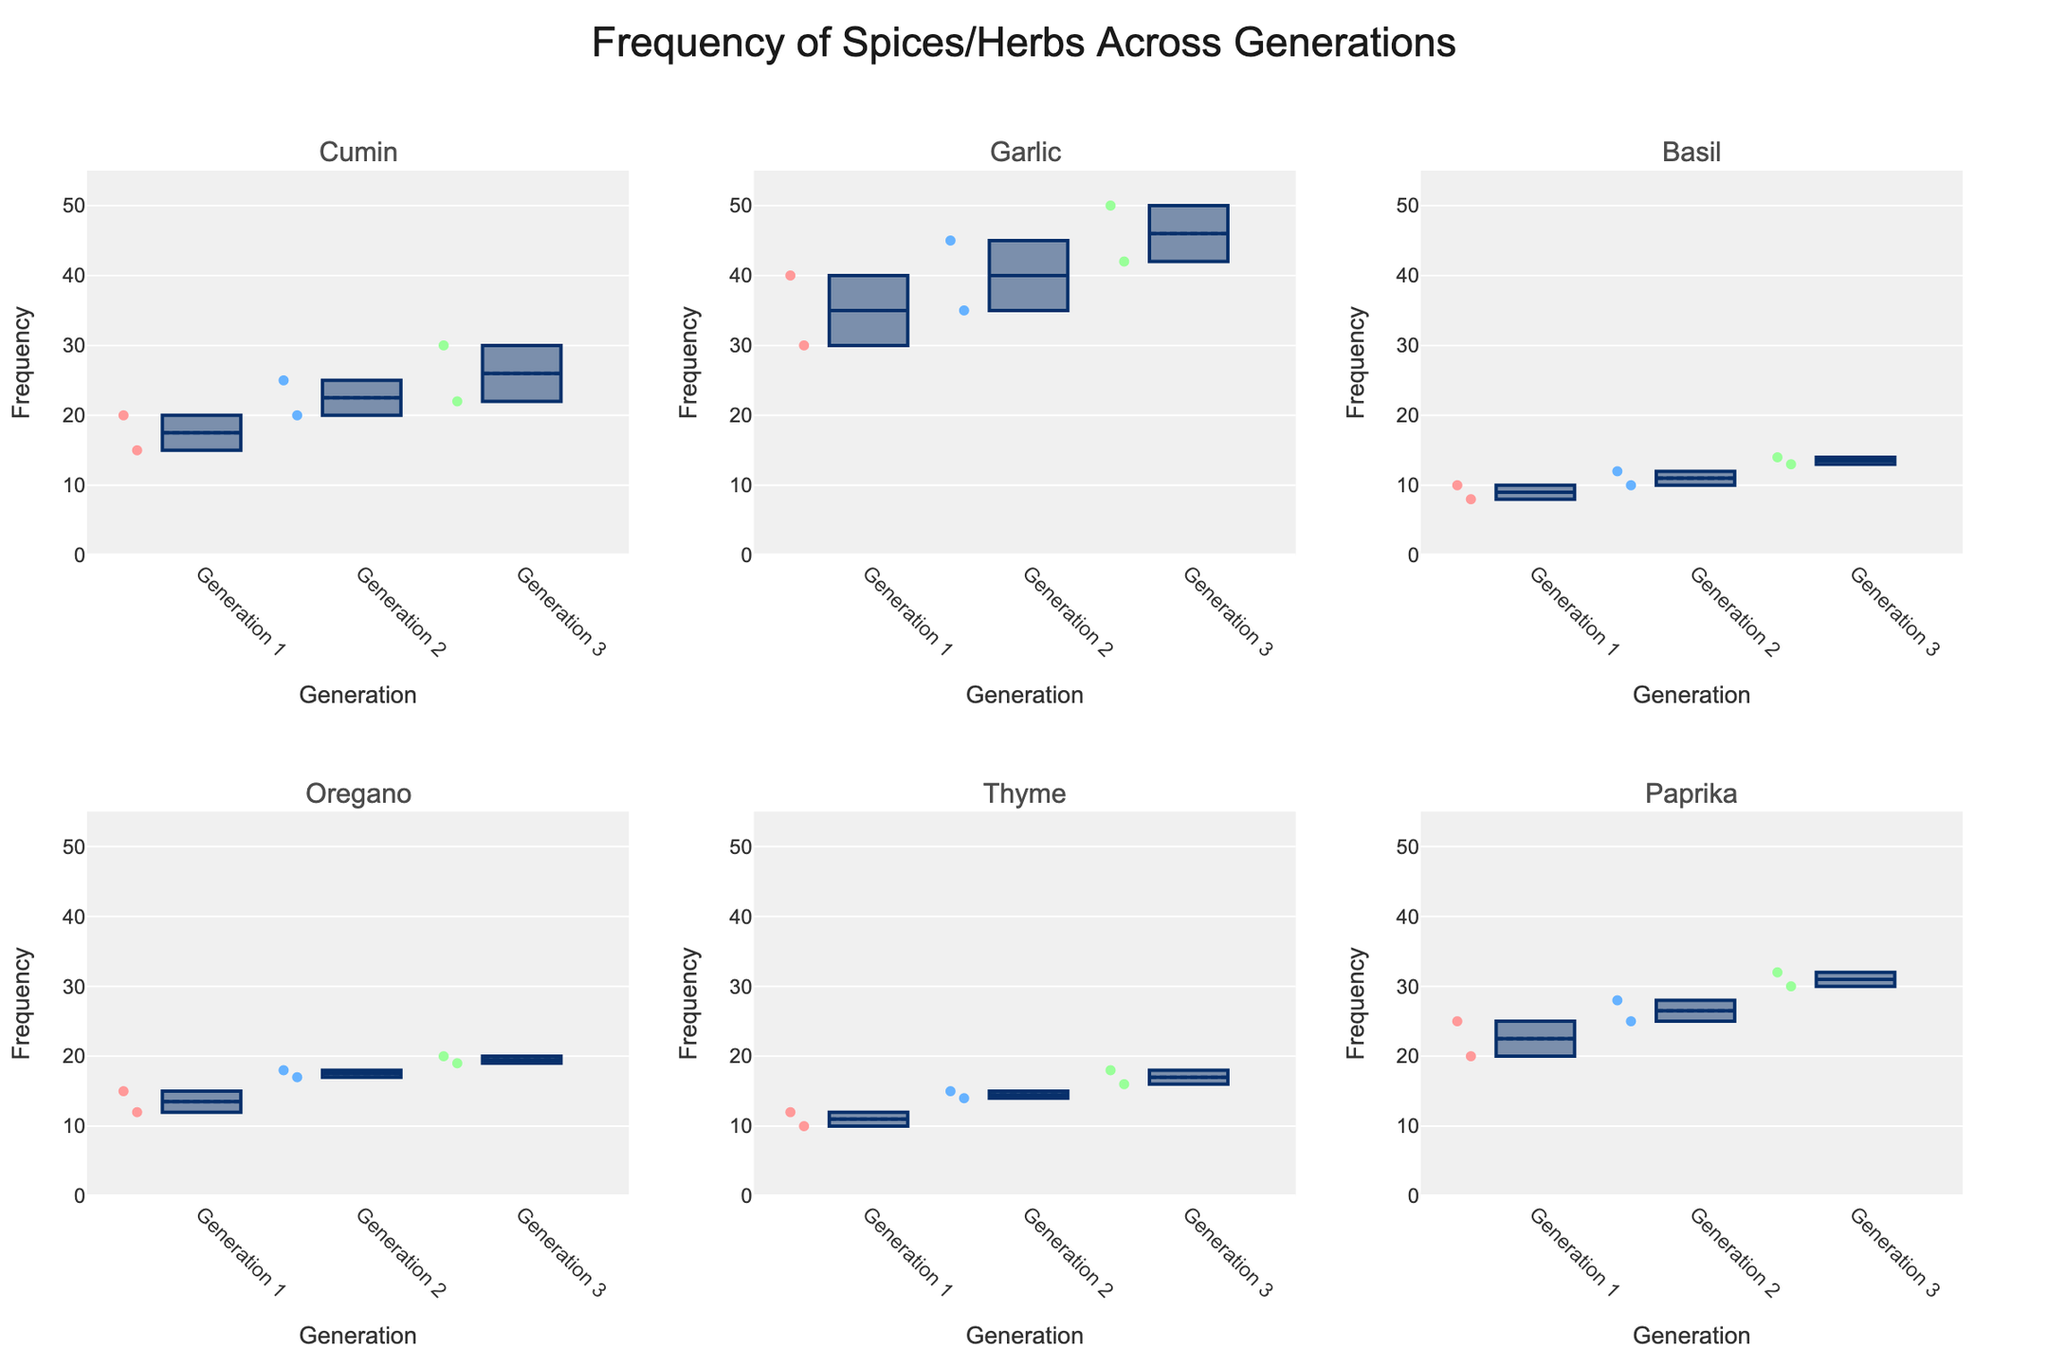What's the title of the figure? The title of the figure is located at the top center of the plot. It's designed to give an overview of what the figure represents.
Answer: "Frequency of Spices/Herbs Across Generations" How many generations are represented in the plot? The x-axes of the subplots are labeled with different generations. Each spice or herb's subplot includes three distinct generations.
Answer: 3 Which spice or herb shows the highest frequency for Generation 3? By comparing the top of the whiskers (maximum values) across the Generation 3 box plots for each subplot, we can see that Garlic has the highest frequency.
Answer: Garlic What is the median frequency of Paprika for Generation 1? Locate the Paprika subplot and look for the box labeled Generation 1. The median is represented by the line inside the box.
Answer: 22.5 Which generation uses the least amount of Basil? By examining the heights of the box plots for Basil, particularly the lower whiskers (minimum values), Generation 1 has the lowest values.
Answer: Generation 1 Are there any outliers in the data for Thyme for Generation 3? In the subplot for Thyme, look to see if there are any individual points outside of the whiskers in the Generation 3 box plot.
Answer: No Which spice or herb shows the most consistent frequency across generations (least variation)? By observing the height of the boxes and the length of the whiskers, Basil appears to have the least variation across its generations.
Answer: Basil What is the average difference in the median frequency of Cumin between Generation 1 and Generation 3? The median frequency for Generations 1 and 3 for Cumin must be extracted from their respective boxes in the Cumin subplot. Calculate the difference, and then take the average. For Gen 1 (17.5), and Gen 3 (26), the difference is 8.5
Answer: 8.5 For Oregano in Generation 2, if we exclude the outliers, what is the range of frequencies? Locate the Generation 2 box plot for Oregano. The range is the distance between the bottom whisker (minimum value) and top whisker (maximum value) excluding any points outside whiskers.
Answer: 5 (17-22) Which Generation shows the greatest overall frequency for Thyme? Look at the box plots for Thyme and compare the upper whiskers. Generation 3 has the highest upper whisker.
Answer: Generation 3 